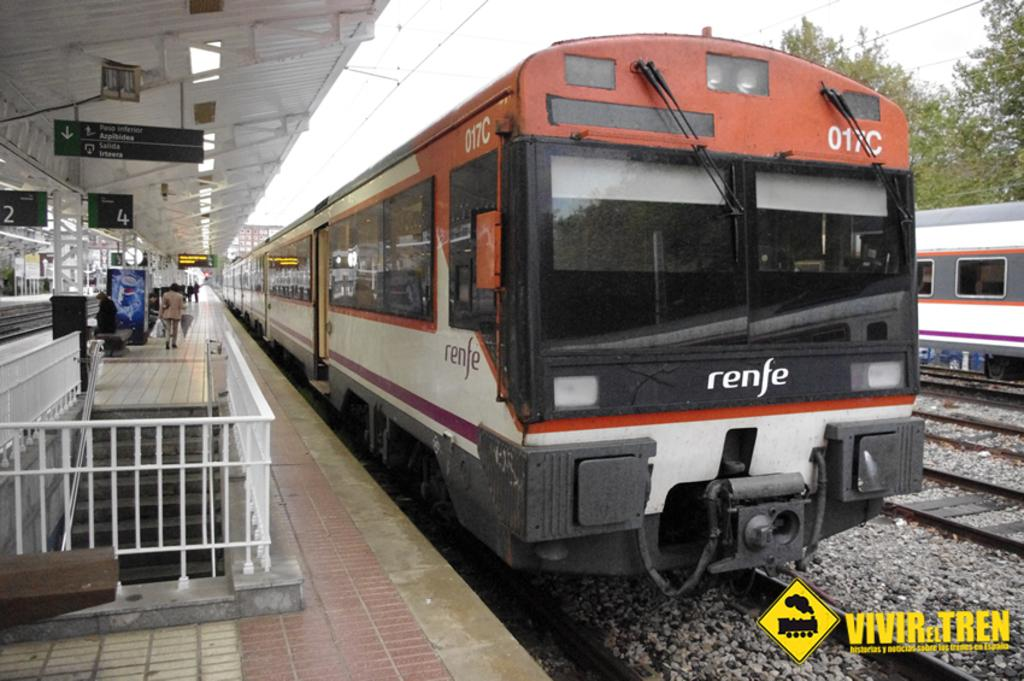<image>
Relay a brief, clear account of the picture shown. A Renfe train has just arrived at a train station. 